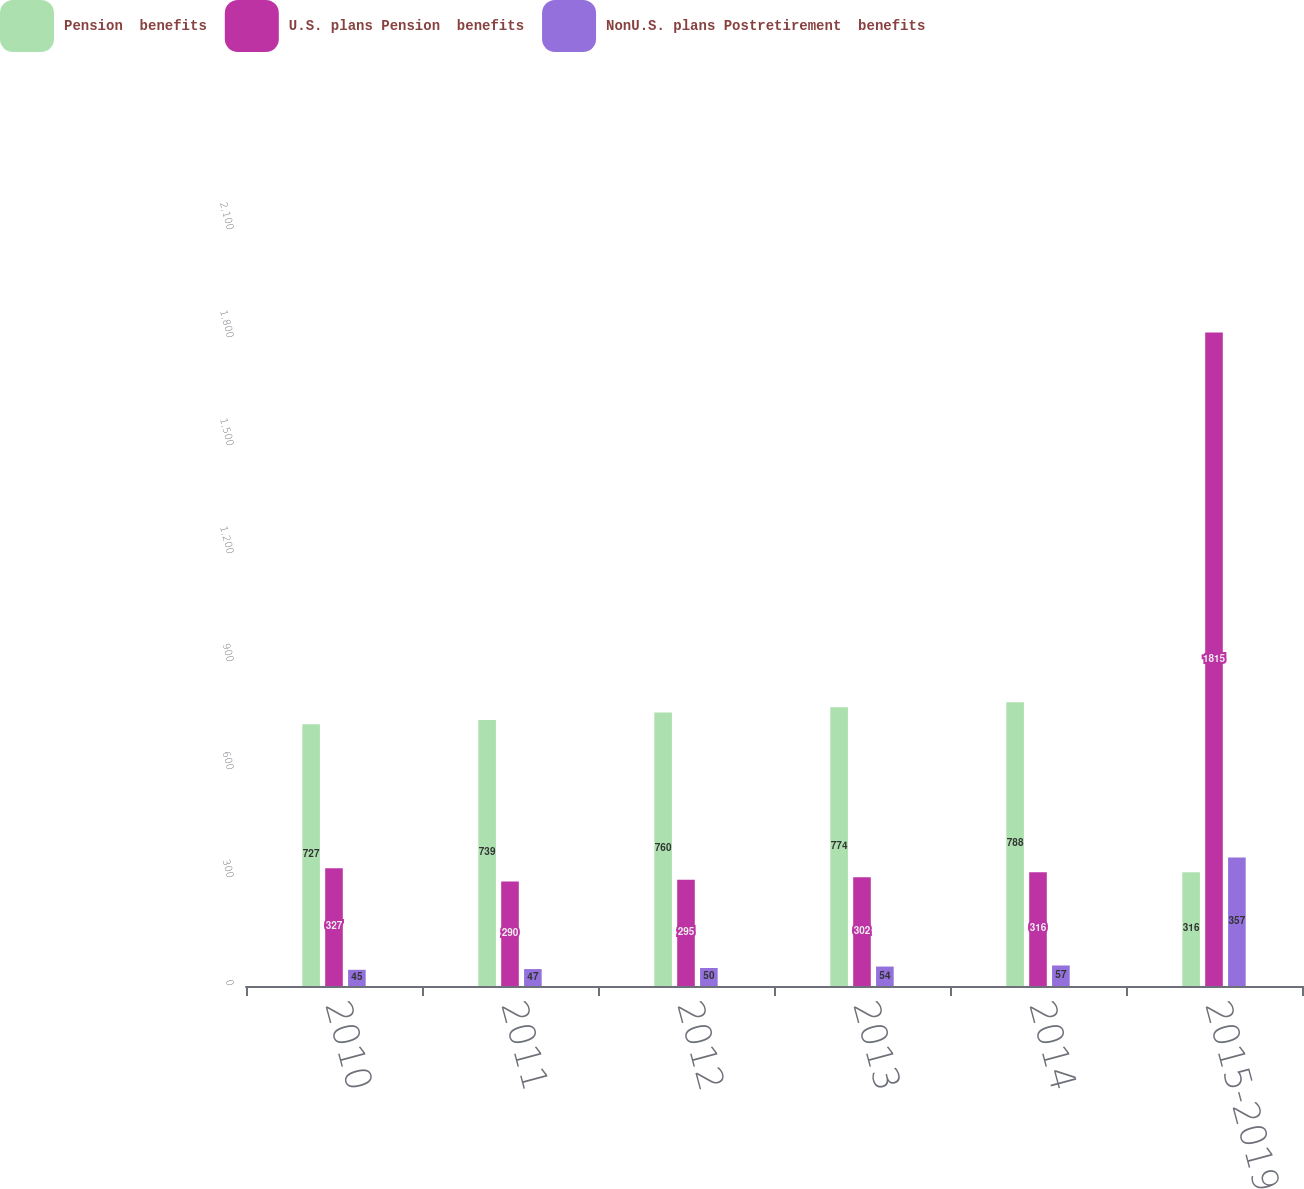<chart> <loc_0><loc_0><loc_500><loc_500><stacked_bar_chart><ecel><fcel>2010<fcel>2011<fcel>2012<fcel>2013<fcel>2014<fcel>2015-2019<nl><fcel>Pension  benefits<fcel>727<fcel>739<fcel>760<fcel>774<fcel>788<fcel>316<nl><fcel>U.S. plans Pension  benefits<fcel>327<fcel>290<fcel>295<fcel>302<fcel>316<fcel>1815<nl><fcel>NonU.S. plans Postretirement  benefits<fcel>45<fcel>47<fcel>50<fcel>54<fcel>57<fcel>357<nl></chart> 